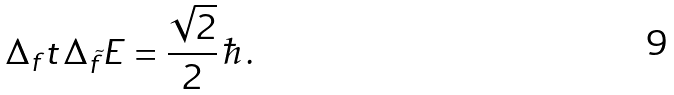Convert formula to latex. <formula><loc_0><loc_0><loc_500><loc_500>\Delta _ { f } t \, \Delta _ { \tilde { f } } E = \frac { \sqrt { 2 } } { 2 } \, \hbar { \, } .</formula> 